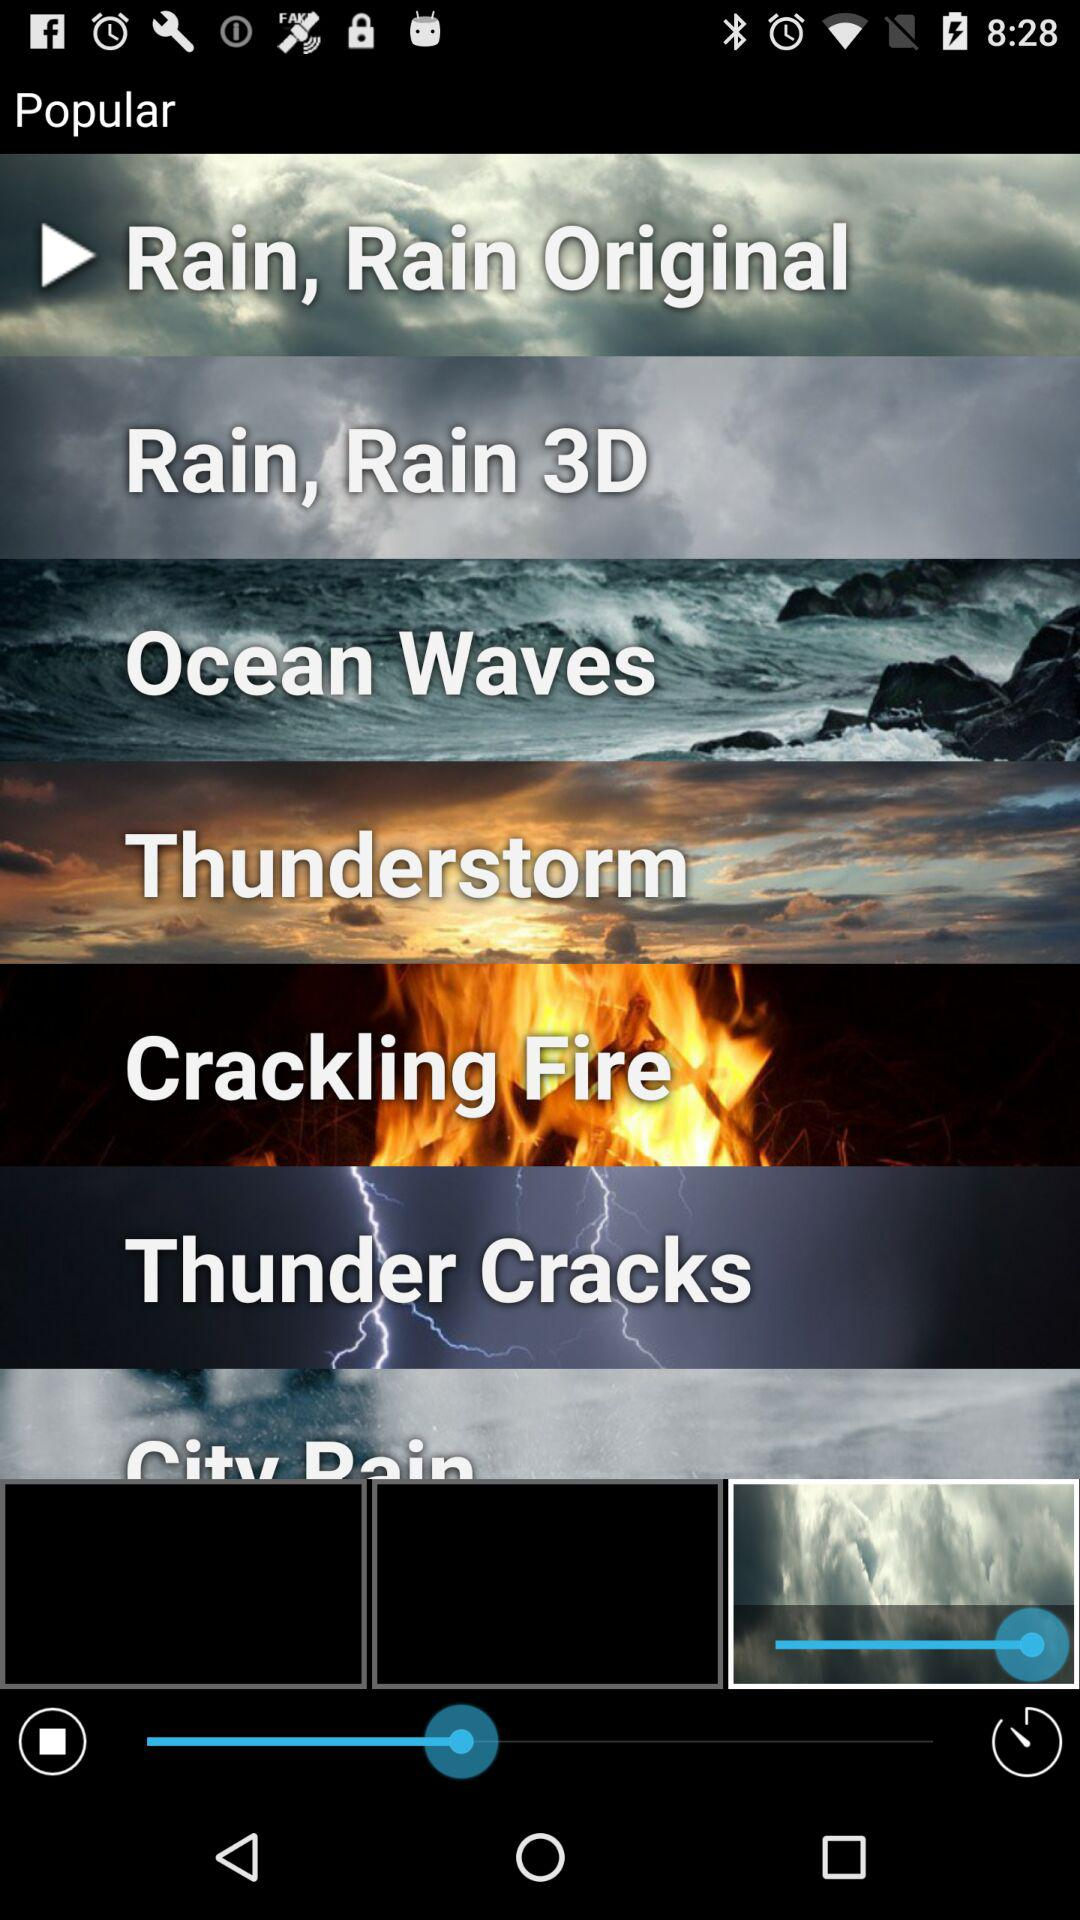Which options are popular?
When the provided information is insufficient, respond with <no answer>. <no answer> 